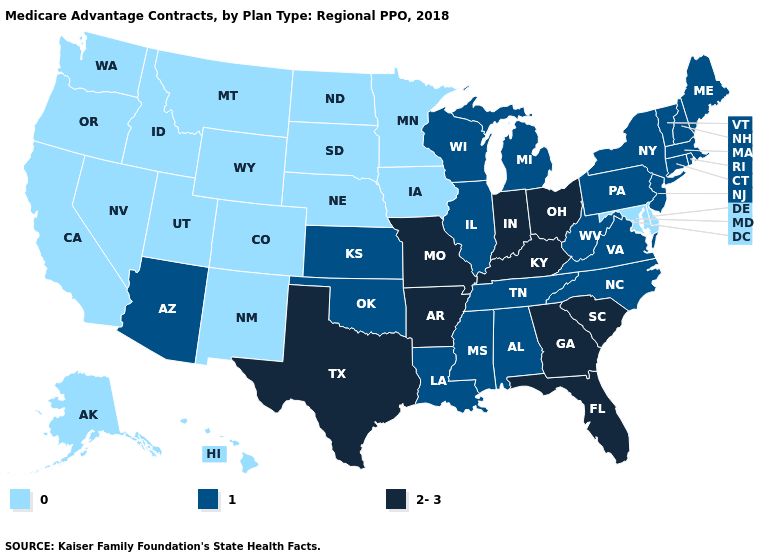What is the value of Maryland?
Keep it brief. 0. What is the value of Kansas?
Answer briefly. 1. Is the legend a continuous bar?
Concise answer only. No. Name the states that have a value in the range 2-3?
Short answer required. Arkansas, Florida, Georgia, Indiana, Kentucky, Missouri, Ohio, South Carolina, Texas. Which states have the highest value in the USA?
Keep it brief. Arkansas, Florida, Georgia, Indiana, Kentucky, Missouri, Ohio, South Carolina, Texas. Does South Carolina have the highest value in the South?
Be succinct. Yes. What is the value of Kansas?
Write a very short answer. 1. Name the states that have a value in the range 0?
Quick response, please. Alaska, California, Colorado, Delaware, Hawaii, Iowa, Idaho, Maryland, Minnesota, Montana, North Dakota, Nebraska, New Mexico, Nevada, Oregon, South Dakota, Utah, Washington, Wyoming. Which states have the lowest value in the South?
Concise answer only. Delaware, Maryland. What is the value of Oklahoma?
Answer briefly. 1. What is the value of Arkansas?
Write a very short answer. 2-3. Does the map have missing data?
Concise answer only. No. Is the legend a continuous bar?
Give a very brief answer. No. What is the highest value in states that border West Virginia?
Write a very short answer. 2-3. Name the states that have a value in the range 1?
Write a very short answer. Alabama, Arizona, Connecticut, Illinois, Kansas, Louisiana, Massachusetts, Maine, Michigan, Mississippi, North Carolina, New Hampshire, New Jersey, New York, Oklahoma, Pennsylvania, Rhode Island, Tennessee, Virginia, Vermont, Wisconsin, West Virginia. 